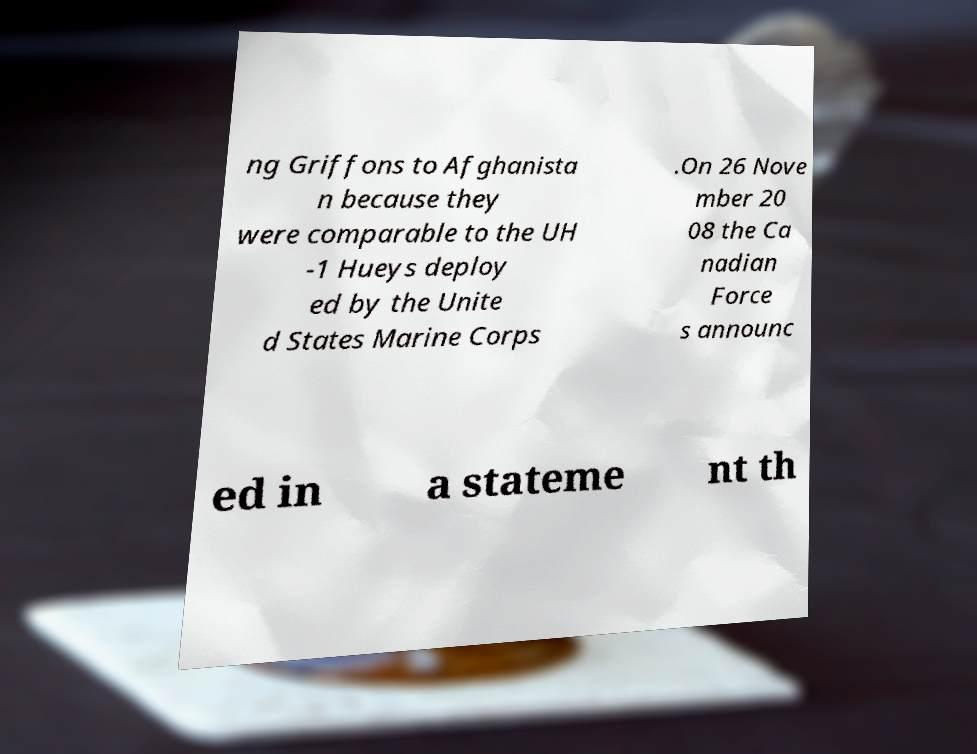There's text embedded in this image that I need extracted. Can you transcribe it verbatim? ng Griffons to Afghanista n because they were comparable to the UH -1 Hueys deploy ed by the Unite d States Marine Corps .On 26 Nove mber 20 08 the Ca nadian Force s announc ed in a stateme nt th 